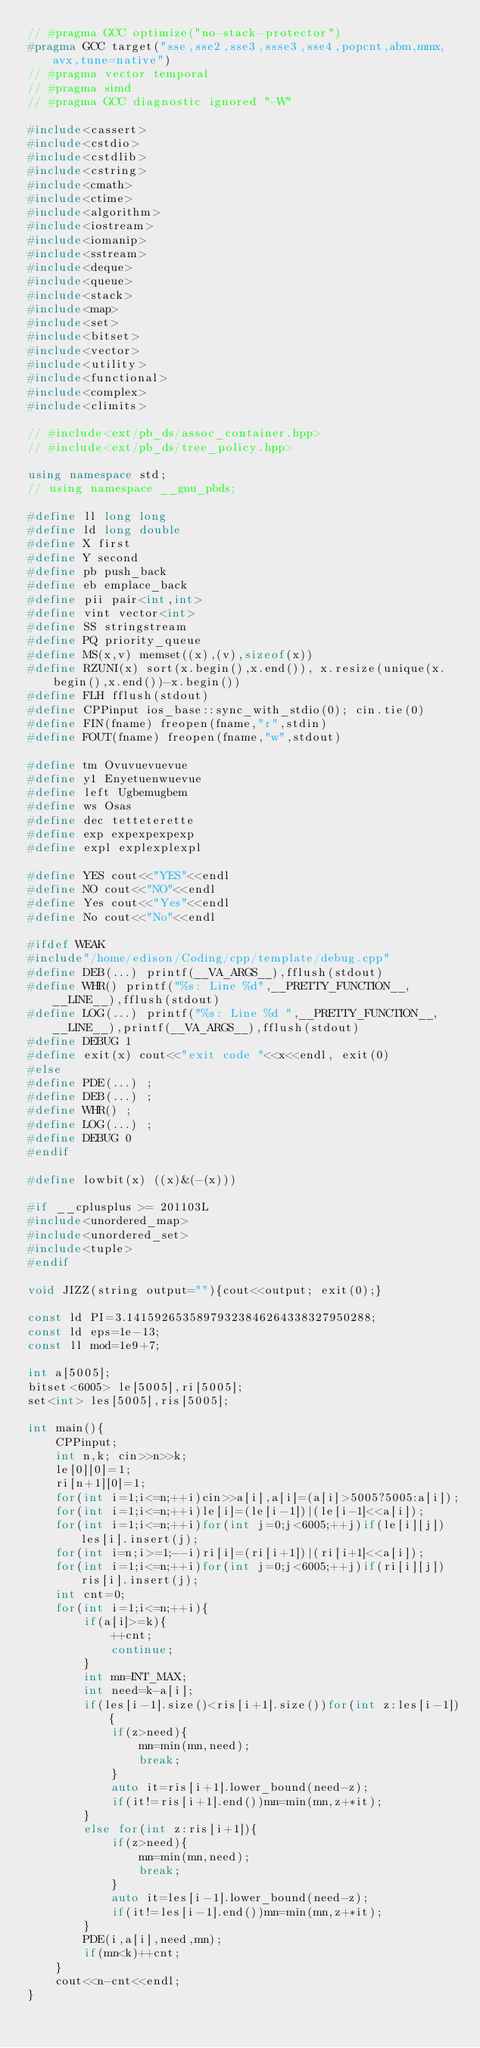Convert code to text. <code><loc_0><loc_0><loc_500><loc_500><_C++_>// #pragma GCC optimize("no-stack-protector")
#pragma GCC target("sse,sse2,sse3,ssse3,sse4,popcnt,abm,mmx,avx,tune=native")
// #pragma vector temporal
// #pragma simd
// #pragma GCC diagnostic ignored "-W"

#include<cassert>
#include<cstdio>
#include<cstdlib>
#include<cstring>
#include<cmath>
#include<ctime>
#include<algorithm>
#include<iostream>
#include<iomanip>
#include<sstream>
#include<deque>
#include<queue>
#include<stack>
#include<map>
#include<set>
#include<bitset>
#include<vector>
#include<utility>
#include<functional>
#include<complex>
#include<climits>

// #include<ext/pb_ds/assoc_container.hpp>
// #include<ext/pb_ds/tree_policy.hpp>

using namespace std;
// using namespace __gnu_pbds;

#define ll long long
#define ld long double
#define X first
#define Y second
#define pb push_back
#define eb emplace_back
#define pii pair<int,int>
#define vint vector<int>
#define SS stringstream
#define PQ priority_queue
#define MS(x,v) memset((x),(v),sizeof(x))
#define RZUNI(x) sort(x.begin(),x.end()), x.resize(unique(x.begin(),x.end())-x.begin())
#define FLH fflush(stdout)
#define CPPinput ios_base::sync_with_stdio(0); cin.tie(0)
#define FIN(fname) freopen(fname,"r",stdin)
#define FOUT(fname) freopen(fname,"w",stdout)

#define tm Ovuvuevuevue
#define y1 Enyetuenwuevue
#define left Ugbemugbem
#define ws Osas
#define dec tetteterette
#define exp expexpexpexp
#define expl explexplexpl

#define YES cout<<"YES"<<endl
#define NO cout<<"NO"<<endl
#define Yes cout<<"Yes"<<endl
#define No cout<<"No"<<endl

#ifdef WEAK
#include"/home/edison/Coding/cpp/template/debug.cpp"
#define DEB(...) printf(__VA_ARGS__),fflush(stdout)
#define WHR() printf("%s: Line %d",__PRETTY_FUNCTION__,__LINE__),fflush(stdout)
#define LOG(...) printf("%s: Line %d ",__PRETTY_FUNCTION__,__LINE__),printf(__VA_ARGS__),fflush(stdout)
#define DEBUG 1
#define exit(x) cout<<"exit code "<<x<<endl, exit(0)
#else
#define PDE(...) ;
#define DEB(...) ;
#define WHR() ;
#define LOG(...) ;
#define DEBUG 0
#endif

#define lowbit(x) ((x)&(-(x)))

#if __cplusplus >= 201103L
#include<unordered_map>
#include<unordered_set>
#include<tuple>
#endif

void JIZZ(string output=""){cout<<output; exit(0);}

const ld PI=3.14159265358979323846264338327950288;
const ld eps=1e-13;
const ll mod=1e9+7;

int a[5005];
bitset<6005> le[5005],ri[5005];
set<int> les[5005],ris[5005];

int main(){
    CPPinput;
    int n,k; cin>>n>>k;
    le[0][0]=1;
    ri[n+1][0]=1;
    for(int i=1;i<=n;++i)cin>>a[i],a[i]=(a[i]>5005?5005:a[i]);
    for(int i=1;i<=n;++i)le[i]=(le[i-1])|(le[i-1]<<a[i]);
    for(int i=1;i<=n;++i)for(int j=0;j<6005;++j)if(le[i][j])les[i].insert(j);
    for(int i=n;i>=1;--i)ri[i]=(ri[i+1])|(ri[i+1]<<a[i]);
    for(int i=1;i<=n;++i)for(int j=0;j<6005;++j)if(ri[i][j])ris[i].insert(j);
    int cnt=0;
    for(int i=1;i<=n;++i){
        if(a[i]>=k){
            ++cnt;
            continue;
        }
        int mn=INT_MAX;
        int need=k-a[i];
        if(les[i-1].size()<ris[i+1].size())for(int z:les[i-1]){
            if(z>need){
                mn=min(mn,need);
                break;
            }
            auto it=ris[i+1].lower_bound(need-z);
            if(it!=ris[i+1].end())mn=min(mn,z+*it);
        }
        else for(int z:ris[i+1]){
            if(z>need){
                mn=min(mn,need);
                break;
            }
            auto it=les[i-1].lower_bound(need-z);
            if(it!=les[i-1].end())mn=min(mn,z+*it);
        }
        PDE(i,a[i],need,mn);
        if(mn<k)++cnt;
    }
    cout<<n-cnt<<endl;
}
</code> 